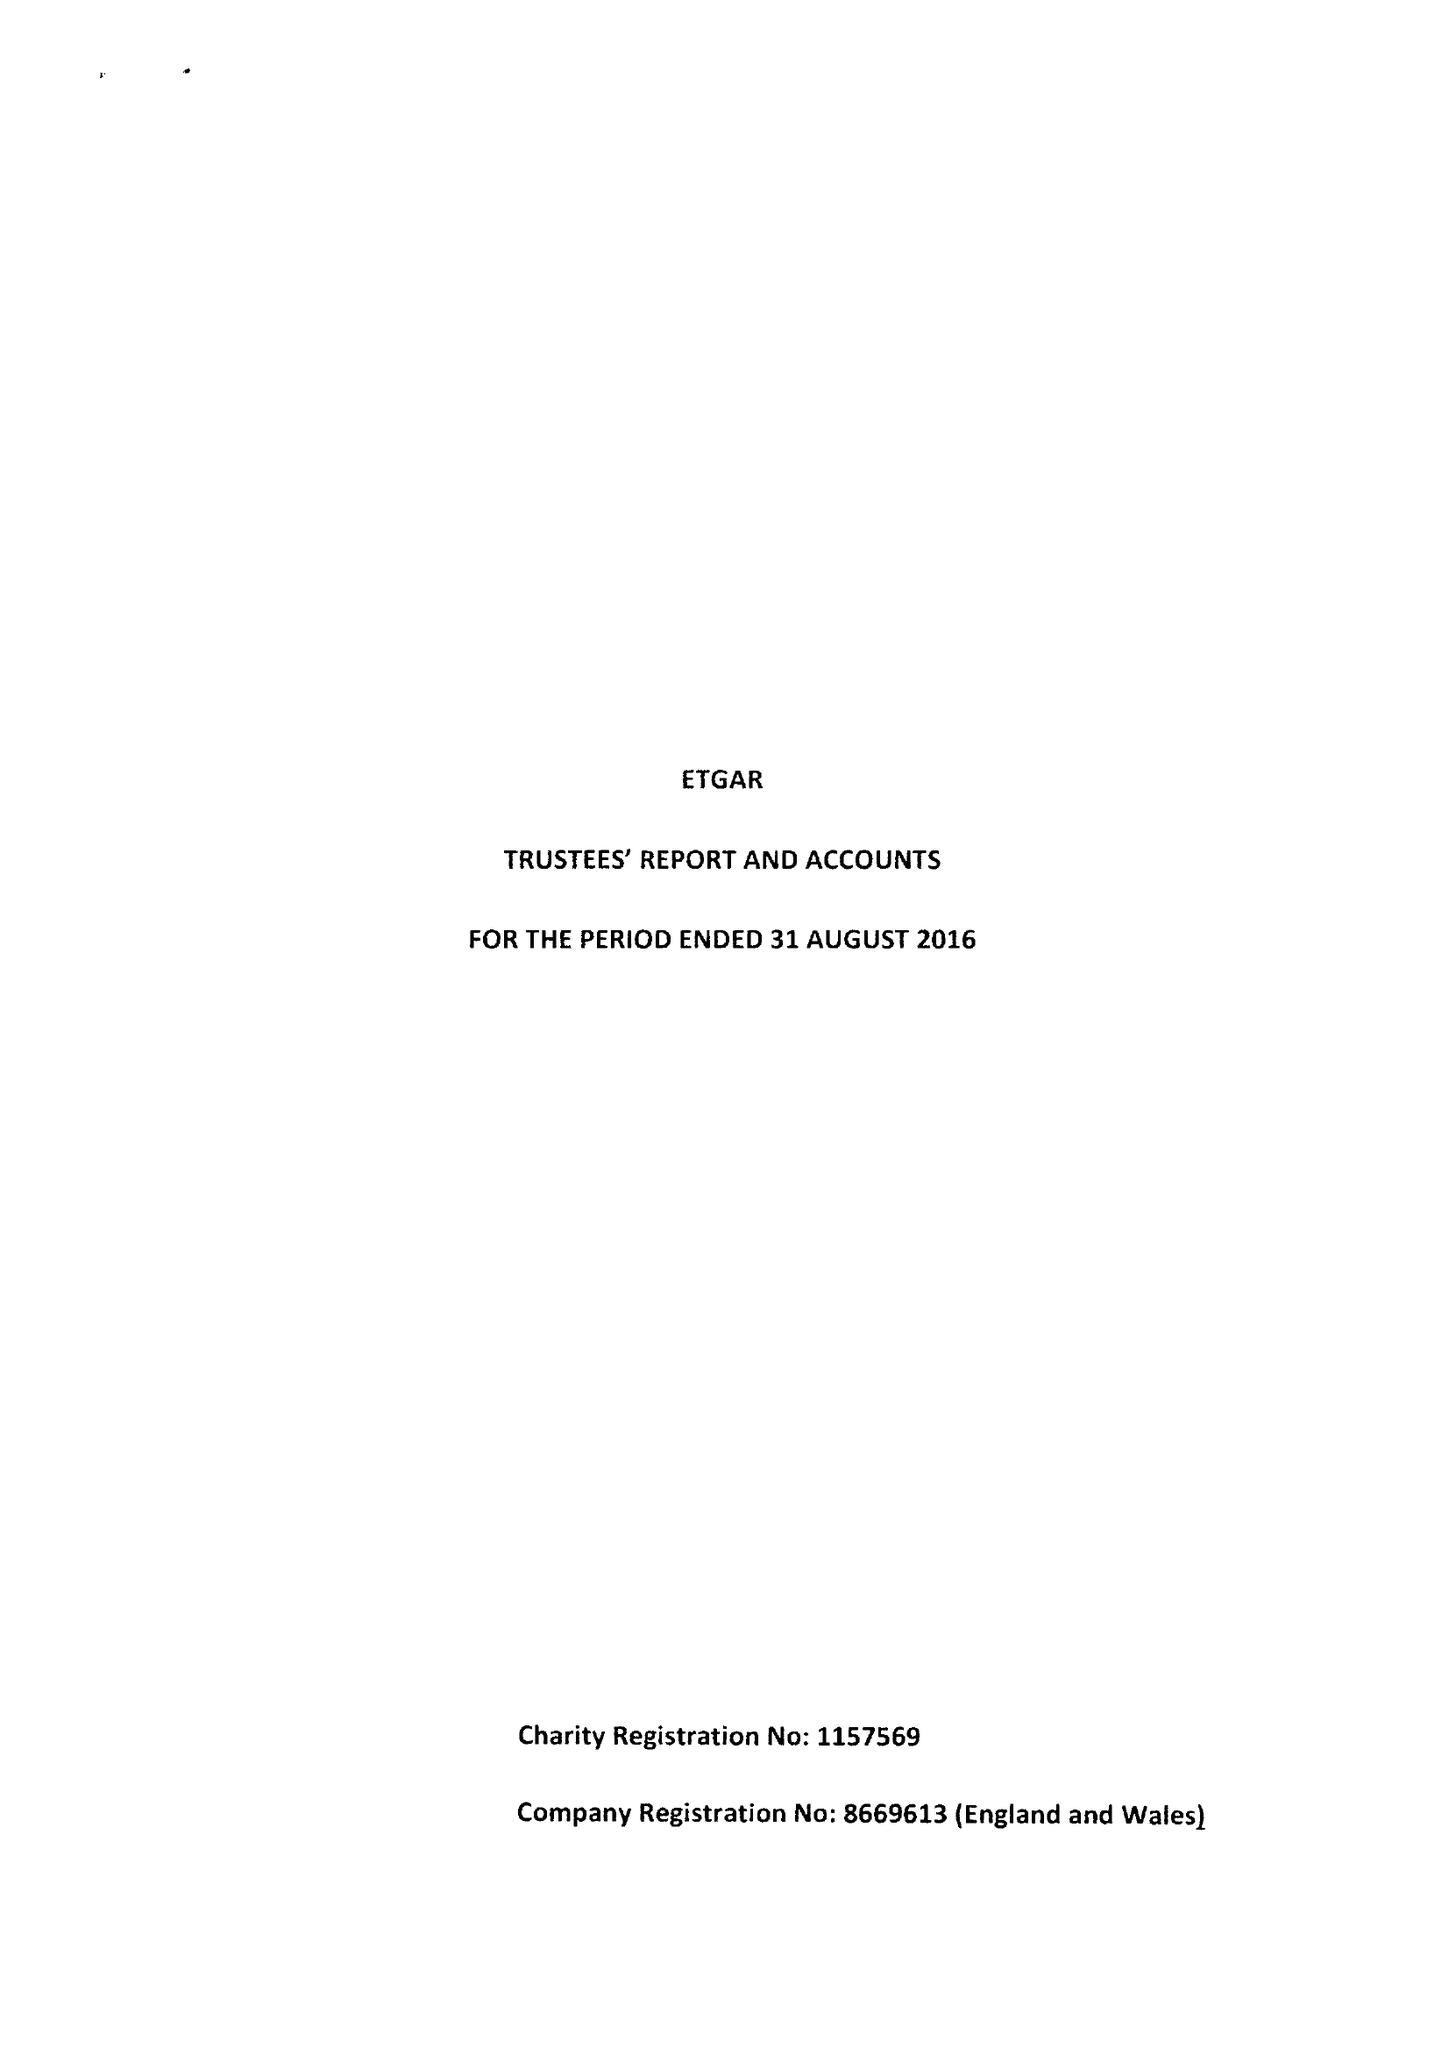What is the value for the address__street_line?
Answer the question using a single word or phrase. PO BOX 698 